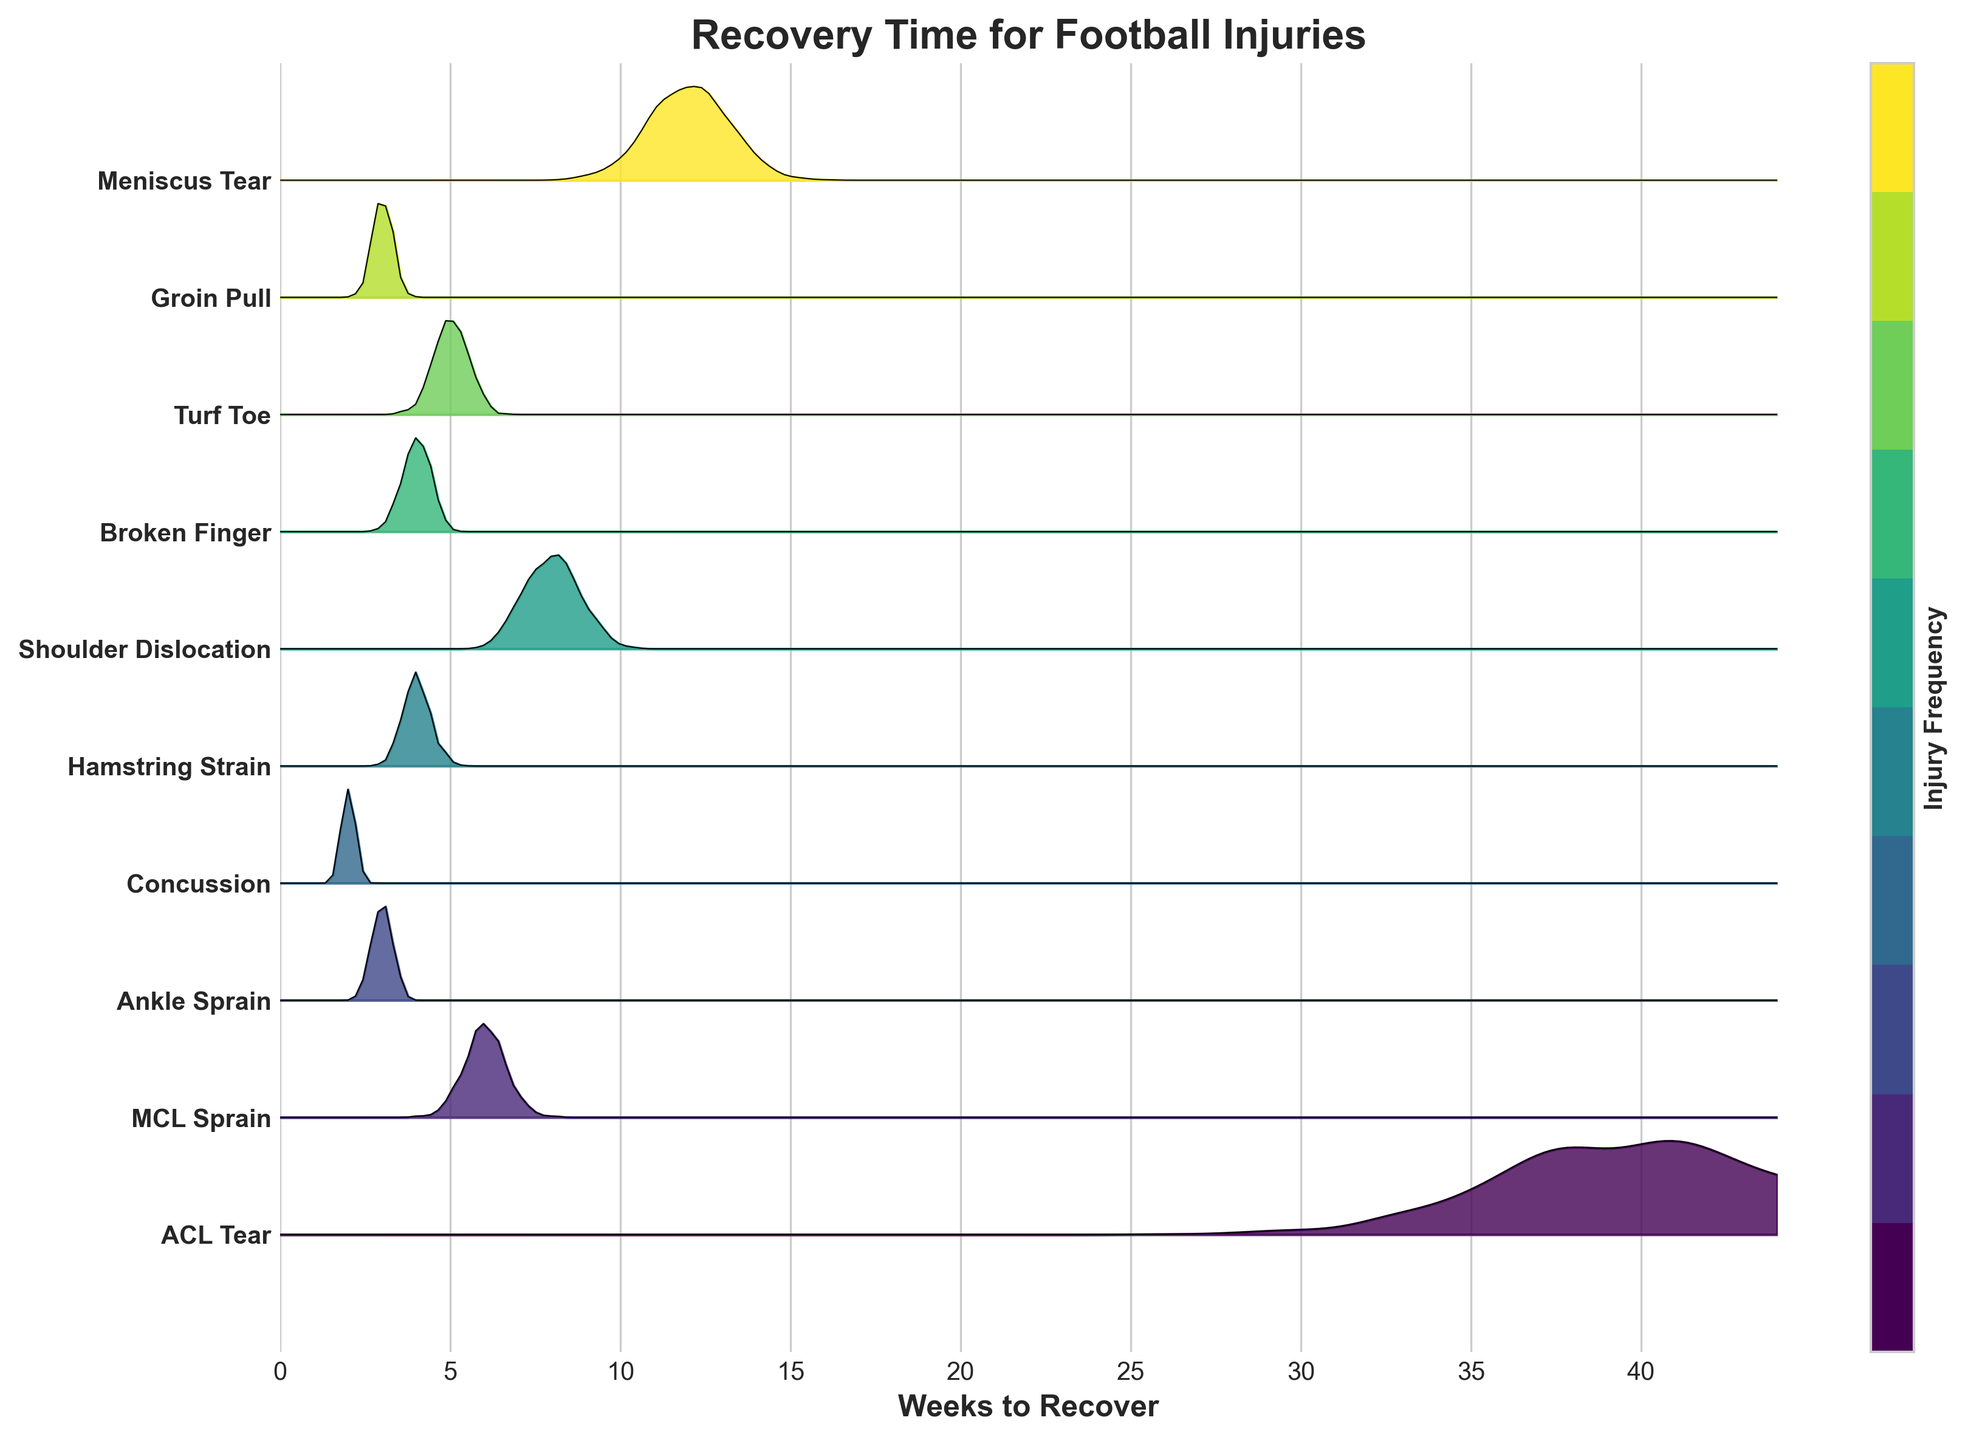What is the title of the figure? The title is located at the top of the figure. It summarizes the content which is about the recovery times for various football injuries.
Answer: Recovery Time for Football Injuries Which injury type has the longest recovery time? To find the injury type with the longest recovery time, we need to look at the labels on the y-axis and compare their corresponding recovery times. The topmost peak on the x-axis reaches about 40 weeks, which is labeled as an ACL tear.
Answer: ACL Tear How many weeks does it take to recover from a Concussion? Find the label for "Concussion" on the y-axis and trace its corresponding x-axis value. The peak for concussion recovery time is at 2 weeks.
Answer: 2 weeks What is the shortest and longest recovery time displayed in the plot? Identify the lowest and highest points on the x-axis across all ridges. The minimum is at 2 weeks (Concussion), and the maximum is at 40 weeks (ACL Tear).
Answer: 2 weeks, 40 weeks Which injury types have a recovery time of 4 weeks? Locate the peaks at the 4-week mark on the x-axis and match them with the y-axis labels. Hamstring Strain and Broken Finger both peak at around 4 weeks.
Answer: Hamstring Strain, Broken Finger How does the recovery time for an Ankle Sprain compare to that for a MCL Sprain? Locate both injury types on the y-axis and see where their peaks align on the x-axis. Ankle Sprain recovery peaks at 3 weeks, while MCL Sprain peaks at 6 weeks, making the Ankle Sprain recovery time shorter.
Answer: Ankle Sprain is shorter What can you infer about the frequency of injuries based on this plot? Observe the density and height of the ridgeline plot sections. Denser and taller sections indicate higher frequencies. For example, Ankle Sprains and Concussions have taller and denser ridgelines, suggesting they are more common.
Answer: Ankle Sprains and Concussions are more common Is there any injury with the same recovery time as Groin Pull? Find Groin Pull on the y-axis and see its corresponding recovery time on the x-axis, then check for other peaks at the same point. Groin Pull peaks at 3 weeks, the same as Ankle Sprain.
Answer: Ankle Sprain How does the recovery distribution for an ACL Tear appear on the plot? Observe the shape and spread of the ridgeline for ACL Tear. The distribution shows a peak at 40 weeks, with a relatively narrow spread, indicating most recoveries cluster close to this time frame.
Answer: Narrow peak at 40 weeks Which injuries have a recovery time between 7 and 9 weeks? Identify the range on the x-axis between 7 and 9 weeks and look for peaks within this range. Shoulder Dislocation, with a peak at 8 weeks, falls in this range.
Answer: Shoulder Dislocation 